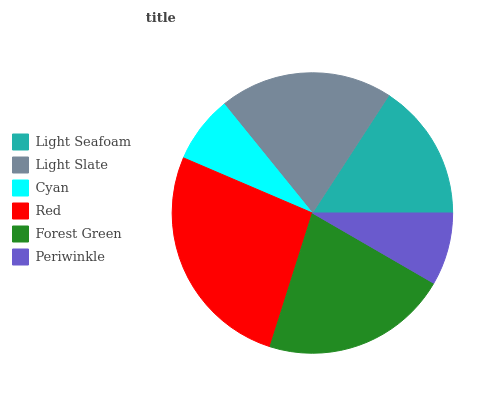Is Cyan the minimum?
Answer yes or no. Yes. Is Red the maximum?
Answer yes or no. Yes. Is Light Slate the minimum?
Answer yes or no. No. Is Light Slate the maximum?
Answer yes or no. No. Is Light Slate greater than Light Seafoam?
Answer yes or no. Yes. Is Light Seafoam less than Light Slate?
Answer yes or no. Yes. Is Light Seafoam greater than Light Slate?
Answer yes or no. No. Is Light Slate less than Light Seafoam?
Answer yes or no. No. Is Light Slate the high median?
Answer yes or no. Yes. Is Light Seafoam the low median?
Answer yes or no. Yes. Is Light Seafoam the high median?
Answer yes or no. No. Is Cyan the low median?
Answer yes or no. No. 